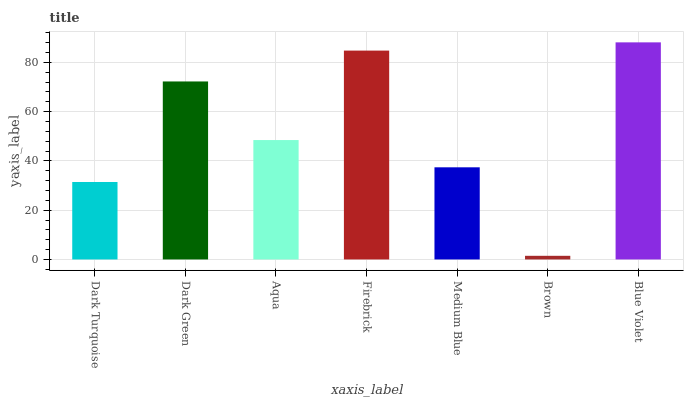Is Dark Green the minimum?
Answer yes or no. No. Is Dark Green the maximum?
Answer yes or no. No. Is Dark Green greater than Dark Turquoise?
Answer yes or no. Yes. Is Dark Turquoise less than Dark Green?
Answer yes or no. Yes. Is Dark Turquoise greater than Dark Green?
Answer yes or no. No. Is Dark Green less than Dark Turquoise?
Answer yes or no. No. Is Aqua the high median?
Answer yes or no. Yes. Is Aqua the low median?
Answer yes or no. Yes. Is Brown the high median?
Answer yes or no. No. Is Dark Green the low median?
Answer yes or no. No. 